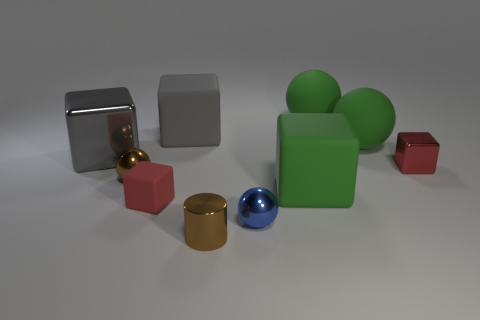Subtract 1 cubes. How many cubes are left? 4 Subtract all green cubes. How many cubes are left? 4 Subtract all big green matte blocks. How many blocks are left? 4 Subtract all cyan cubes. Subtract all brown balls. How many cubes are left? 5 Subtract all balls. How many objects are left? 6 Add 2 tiny matte objects. How many tiny matte objects exist? 3 Subtract 1 blue spheres. How many objects are left? 9 Subtract all big matte objects. Subtract all matte spheres. How many objects are left? 4 Add 1 big rubber objects. How many big rubber objects are left? 5 